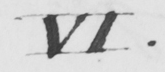What does this handwritten line say? VI . 